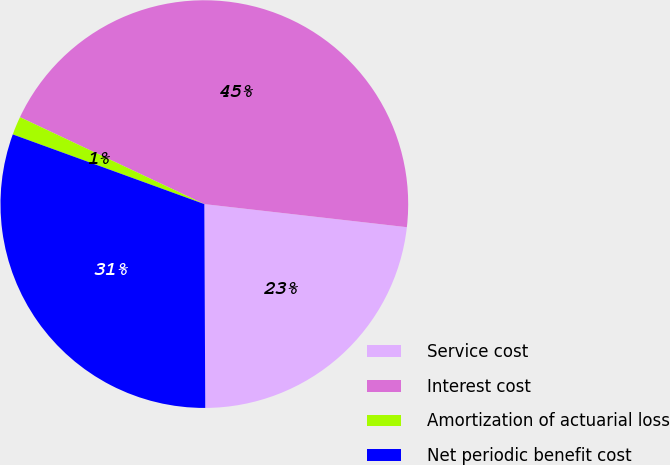Convert chart to OTSL. <chart><loc_0><loc_0><loc_500><loc_500><pie_chart><fcel>Service cost<fcel>Interest cost<fcel>Amortization of actuarial loss<fcel>Net periodic benefit cost<nl><fcel>23.12%<fcel>44.79%<fcel>1.46%<fcel>30.62%<nl></chart> 